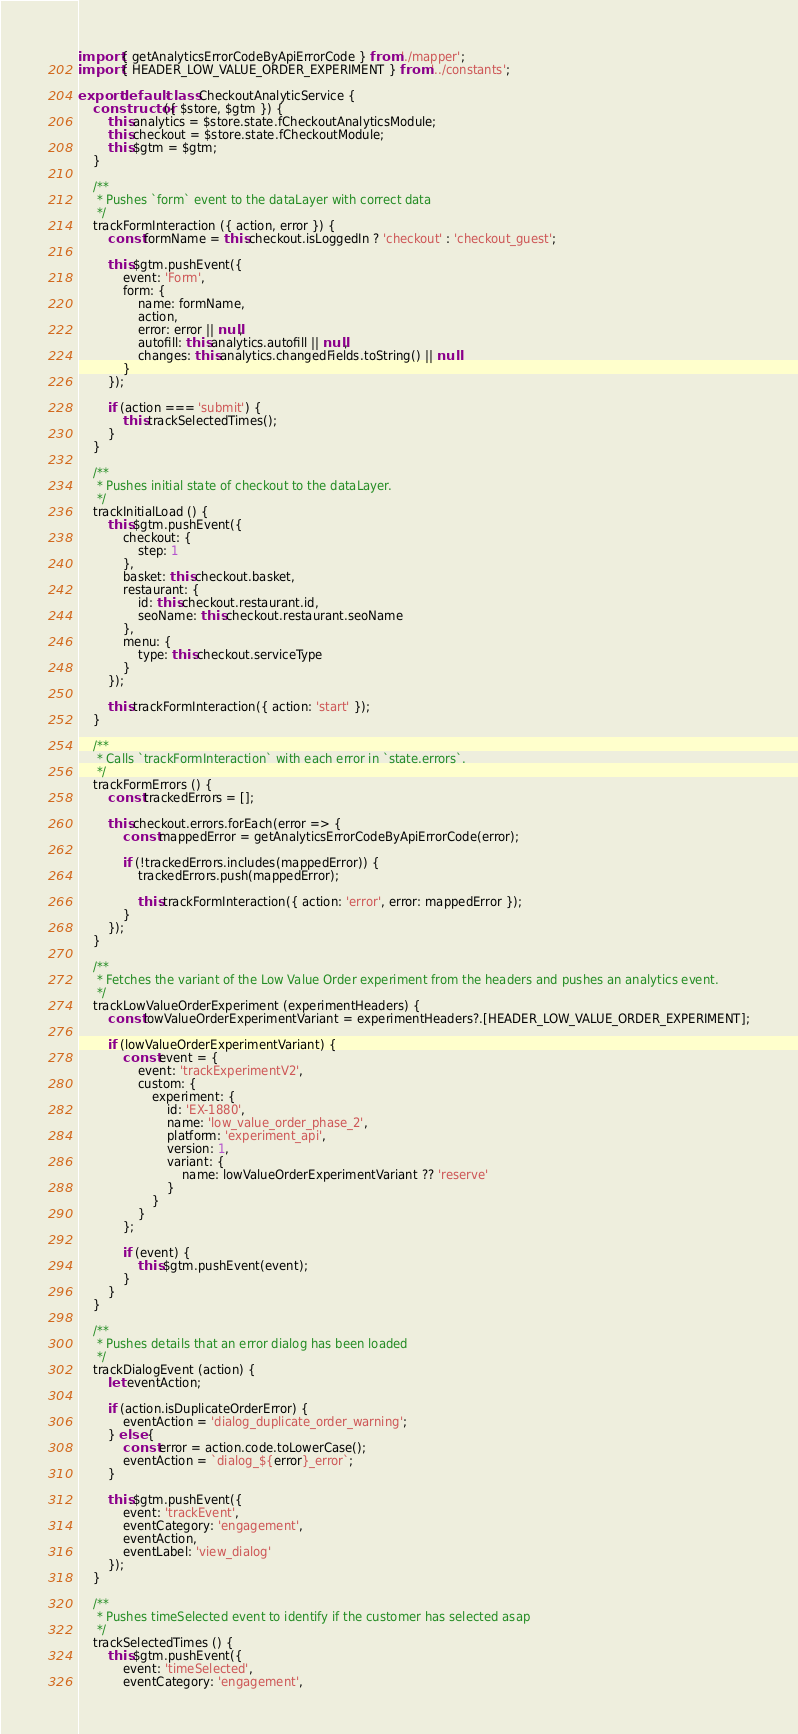Convert code to text. <code><loc_0><loc_0><loc_500><loc_500><_JavaScript_>import { getAnalyticsErrorCodeByApiErrorCode } from './mapper';
import { HEADER_LOW_VALUE_ORDER_EXPERIMENT } from '../constants';

export default class CheckoutAnalyticService {
    constructor ({ $store, $gtm }) {
        this.analytics = $store.state.fCheckoutAnalyticsModule;
        this.checkout = $store.state.fCheckoutModule;
        this.$gtm = $gtm;
    }

    /**
     * Pushes `form` event to the dataLayer with correct data
     */
    trackFormInteraction ({ action, error }) {
        const formName = this.checkout.isLoggedIn ? 'checkout' : 'checkout_guest';

        this.$gtm.pushEvent({
            event: 'Form',
            form: {
                name: formName,
                action,
                error: error || null,
                autofill: this.analytics.autofill || null,
                changes: this.analytics.changedFields.toString() || null
            }
        });

        if (action === 'submit') {
            this.trackSelectedTimes();
        }
    }

    /**
     * Pushes initial state of checkout to the dataLayer.
     */
    trackInitialLoad () {
        this.$gtm.pushEvent({
            checkout: {
                step: 1
            },
            basket: this.checkout.basket,
            restaurant: {
                id: this.checkout.restaurant.id,
                seoName: this.checkout.restaurant.seoName
            },
            menu: {
                type: this.checkout.serviceType
            }
        });

        this.trackFormInteraction({ action: 'start' });
    }

    /**
     * Calls `trackFormInteraction` with each error in `state.errors`.
     */
    trackFormErrors () {
        const trackedErrors = [];

        this.checkout.errors.forEach(error => {
            const mappedError = getAnalyticsErrorCodeByApiErrorCode(error);

            if (!trackedErrors.includes(mappedError)) {
                trackedErrors.push(mappedError);

                this.trackFormInteraction({ action: 'error', error: mappedError });
            }
        });
    }

    /**
     * Fetches the variant of the Low Value Order experiment from the headers and pushes an analytics event.
     */
    trackLowValueOrderExperiment (experimentHeaders) {
        const lowValueOrderExperimentVariant = experimentHeaders?.[HEADER_LOW_VALUE_ORDER_EXPERIMENT];

        if (lowValueOrderExperimentVariant) {
            const event = {
                event: 'trackExperimentV2',
                custom: {
                    experiment: {
                        id: 'EX-1880',
                        name: 'low_value_order_phase_2',
                        platform: 'experiment_api',
                        version: 1,
                        variant: {
                            name: lowValueOrderExperimentVariant ?? 'reserve'
                        }
                    }
                }
            };

            if (event) {
                this.$gtm.pushEvent(event);
            }
        }
    }

    /**
     * Pushes details that an error dialog has been loaded
     */
    trackDialogEvent (action) {
        let eventAction;

        if (action.isDuplicateOrderError) {
            eventAction = 'dialog_duplicate_order_warning';
        } else {
            const error = action.code.toLowerCase();
            eventAction = `dialog_${error}_error`;
        }

        this.$gtm.pushEvent({
            event: 'trackEvent',
            eventCategory: 'engagement',
            eventAction,
            eventLabel: 'view_dialog'
        });
    }

    /**
     * Pushes timeSelected event to identify if the customer has selected asap
     */
    trackSelectedTimes () {
        this.$gtm.pushEvent({
            event: 'timeSelected',
            eventCategory: 'engagement',</code> 